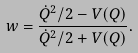<formula> <loc_0><loc_0><loc_500><loc_500>w = \frac { \dot { Q } ^ { 2 } / 2 - V ( Q ) } { \dot { Q } ^ { 2 } / 2 + V ( Q ) } .</formula> 